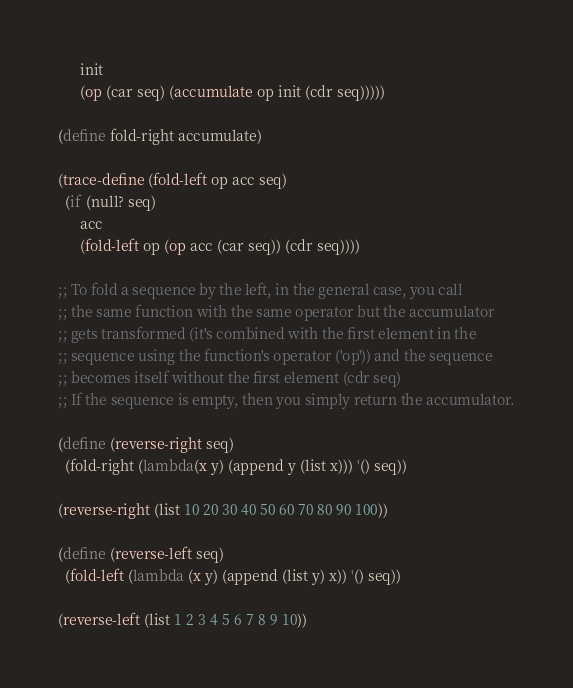<code> <loc_0><loc_0><loc_500><loc_500><_Scheme_>      init
      (op (car seq) (accumulate op init (cdr seq)))))

(define fold-right accumulate)

(trace-define (fold-left op acc seq)
  (if (null? seq)
      acc
      (fold-left op (op acc (car seq)) (cdr seq))))

;; To fold a sequence by the left, in the general case, you call
;; the same function with the same operator but the accumulator
;; gets transformed (it's combined with the first element in the
;; sequence using the function's operator ('op')) and the sequence
;; becomes itself without the first element (cdr seq)
;; If the sequence is empty, then you simply return the accumulator.

(define (reverse-right seq)
  (fold-right (lambda(x y) (append y (list x))) '() seq))

(reverse-right (list 10 20 30 40 50 60 70 80 90 100))

(define (reverse-left seq)
  (fold-left (lambda (x y) (append (list y) x)) '() seq))

(reverse-left (list 1 2 3 4 5 6 7 8 9 10))</code> 